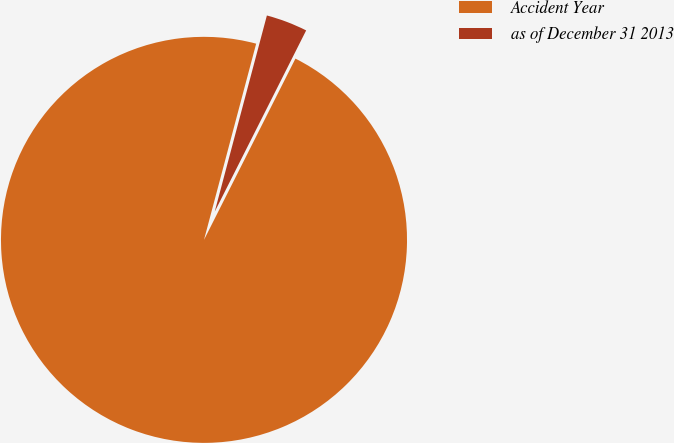Convert chart to OTSL. <chart><loc_0><loc_0><loc_500><loc_500><pie_chart><fcel>Accident Year<fcel>as of December 31 2013<nl><fcel>96.7%<fcel>3.3%<nl></chart> 